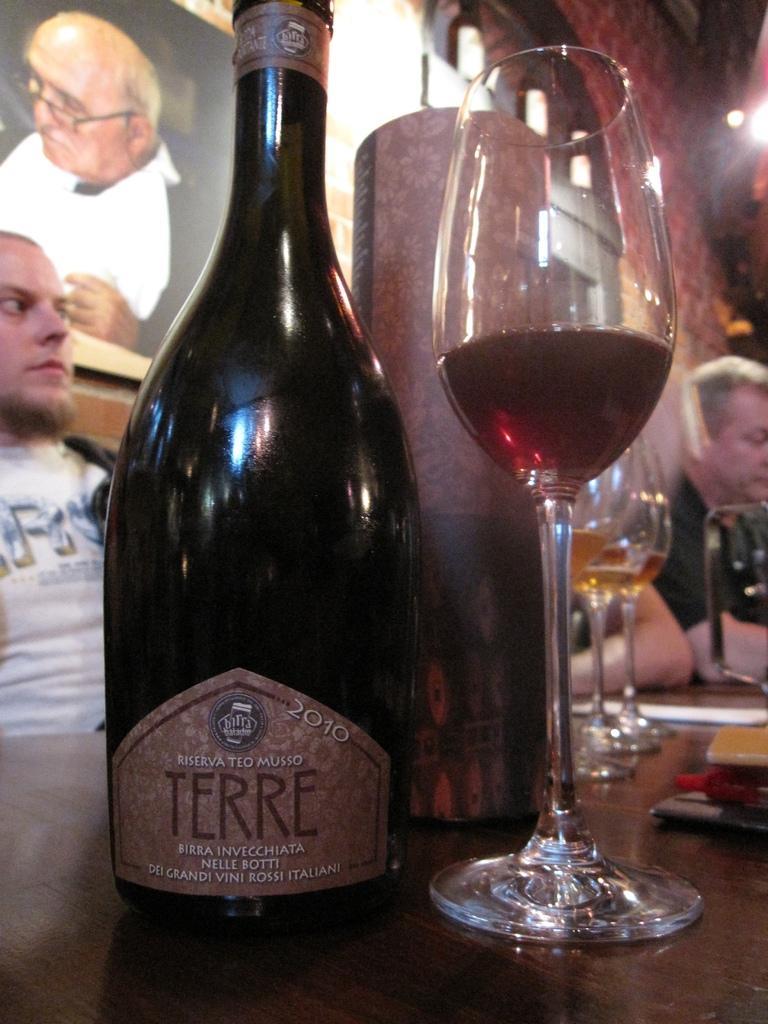How would you summarize this image in a sentence or two? In this image we can see few drinking glasses on the table. There are few objects on the table. There is a photo on the wall. There is a person at the left side of the image. There are few people at the right side of the image. There is a light at the right side of the image. There is a bottle on the table. 